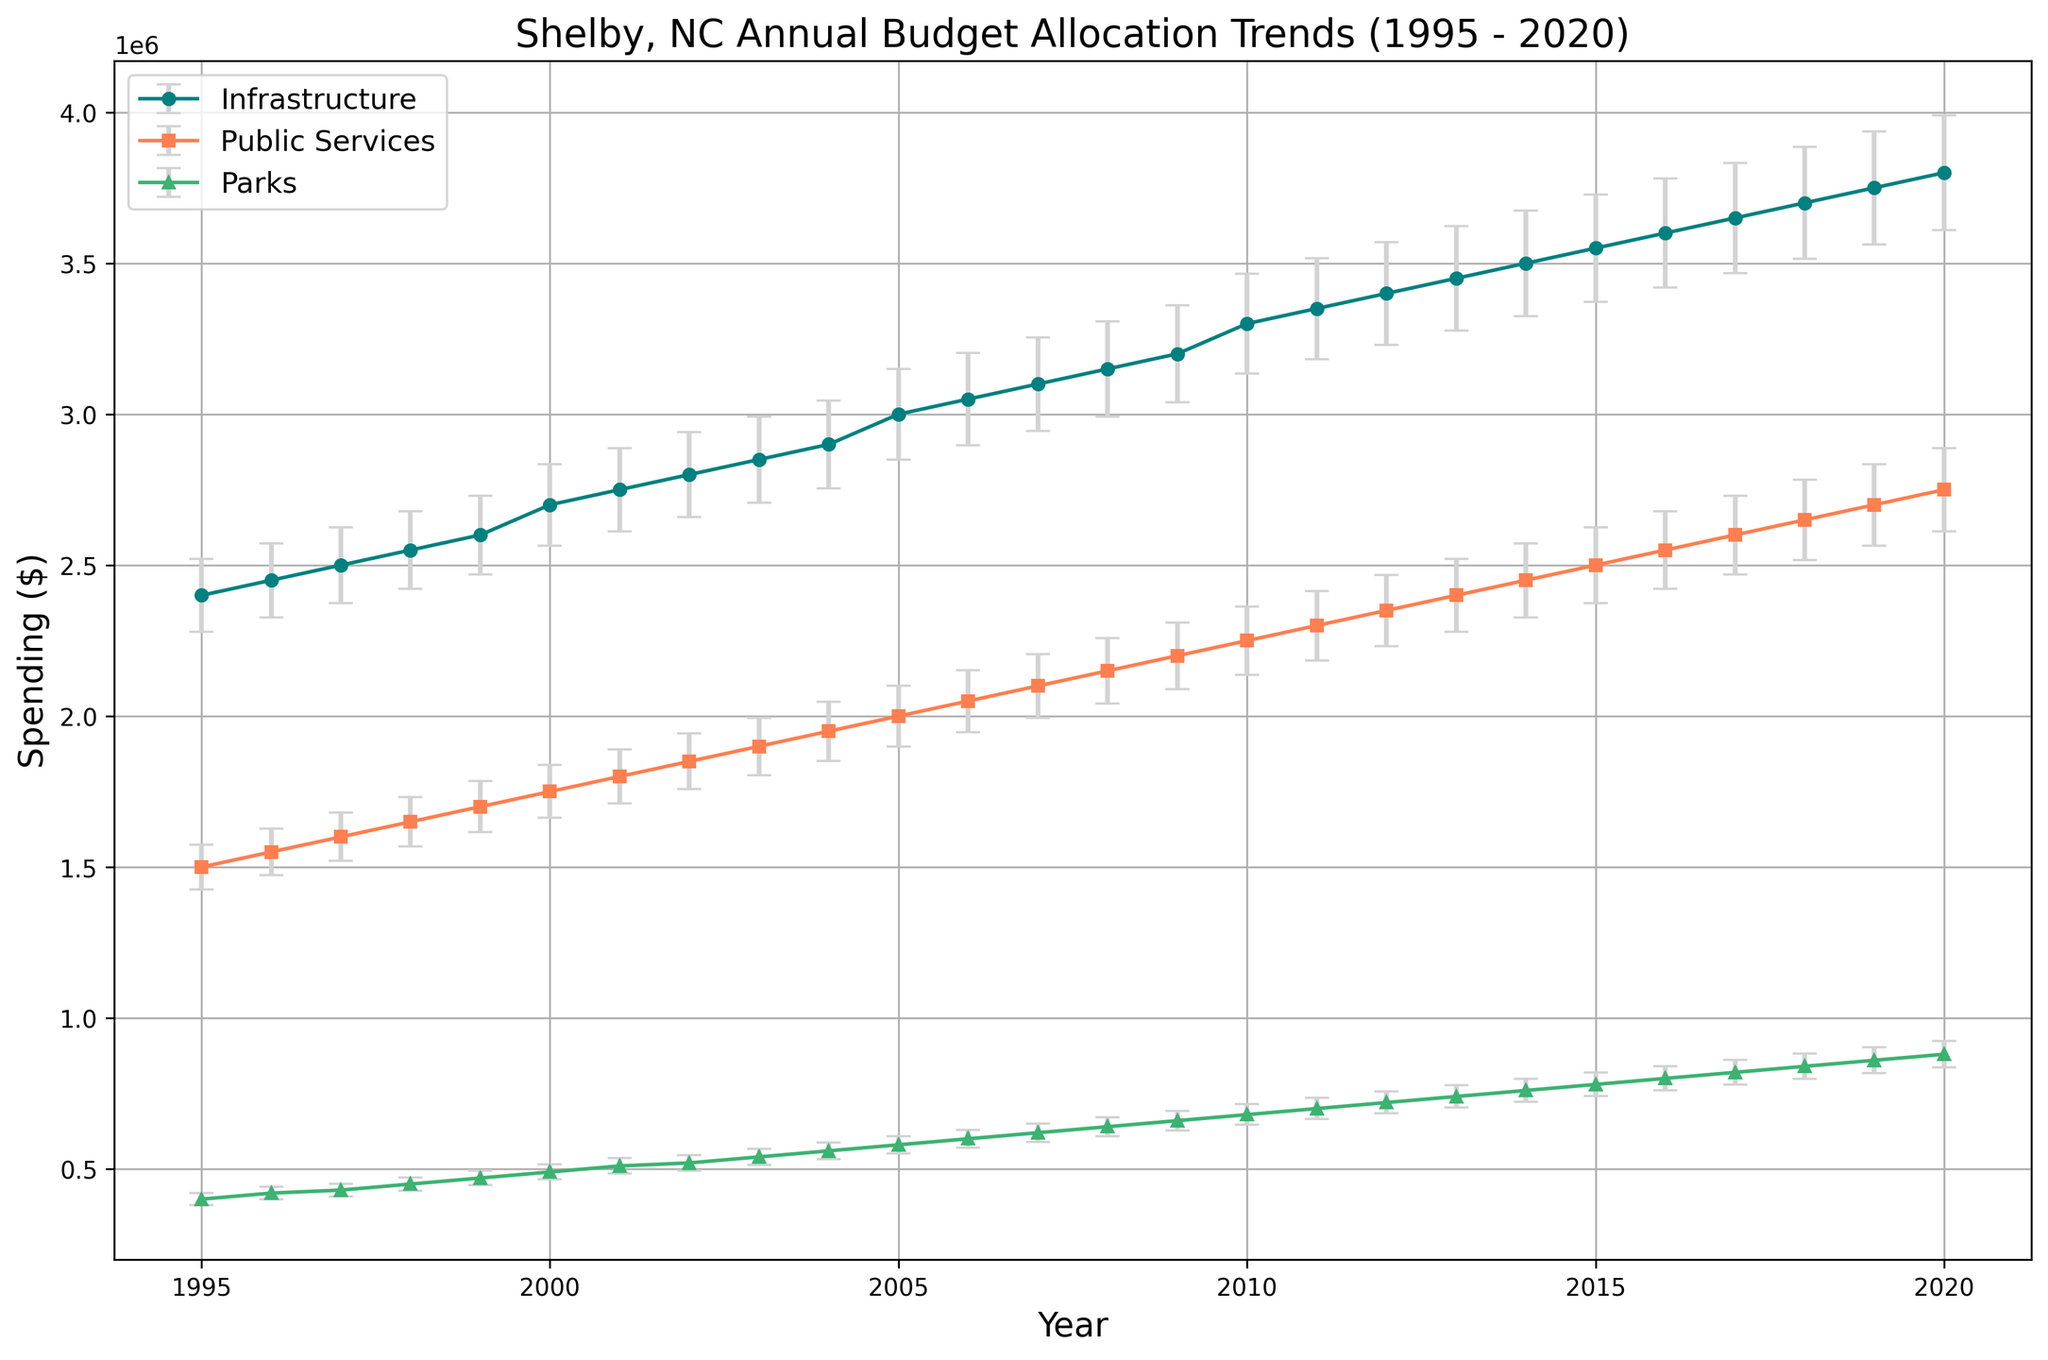What is the average annual spending for infrastructure over the 25 years? To find the average, sum all the infrastructure spending values from 1995 to 2020 and divide by the number of years (25). Summing these values gives $79,500,000. Dividing by 25, we get \( \$3,180,000 \).
Answer: $3,180,000 What was the gap in spending between Public Services and Parks in 2020? To find the gap in spending between Public Services and Parks for a given year, subtract the Parks spending from the Public Services spending for that year. For 2020, it is \( \$2,750,000 - \$880,000 = \$1,870,000 \).
Answer: $1,870,000 How did Infrastructure spending compare to Public Services spending in 2010? To compare the two spendings in 2010, look at the values for each category in 2010. Infrastructure: $3,300,000, Public Services: $2,250,000. Here, Infrastructure spending is greater.
Answer: Infrastructure spending is greater Which category showed the smallest spending uncertainty in 1995? The uncertainties in 1995 are Infrastructure: $120,000, Public Services: $75,000, Parks: $20,000. The smallest value is for Parks.
Answer: Parks What is the total combined spending on Parks over the entire period? Sum the Parks spending values from 1995 to 2020. The sum is \( 400000 + 420000 + 430000 + \cdots + 860000 + 880000 = $17,000,000 \).
Answer: $17,000,000 In which year did Public Services spending reach $2,000,000 for the first time? Examine the Public Services spending values year by year until it first reaches or exceeds $2,000,000. This happens in 2005.
Answer: 2005 Was Infrastructure spending ever less than Public Services spending from 1995 to 2020? Compare the annual values of Infrastructure and Public Services spending for each year from 1995 to 2020. Infrastructure spending is always greater than Public Services spending in every year.
Answer: No In which year does the uncertainty in Parks spending exceed $35,000 for the first time? Examine the uncertainty values for Parks year by year until it first exceeds $35,000. This happens in 2011.
Answer: 2011 How much did Infrastructure spending increase from 1995 to 2020? Subtract the Infrastructure spending in 1995 from that in 2020. $\$3,800,000 - \$2,400,000 = \$1,400,000$.
Answer: $1,400,000 Did any category show a steady increase in spending every year without any year of decrease from 1995 to 2020? Examine the spending values for Infrastructure, Public Services, and Parks year by year from 1995 to 2020. They all show a steady increase every year.
Answer: Yes, all categories 